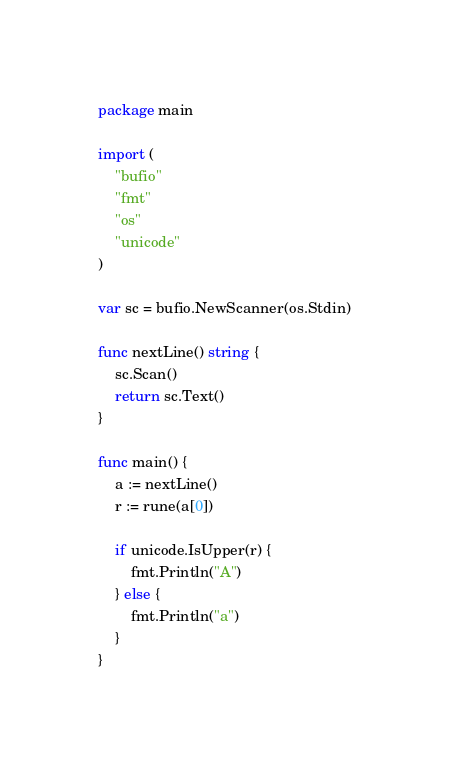<code> <loc_0><loc_0><loc_500><loc_500><_Go_>package main

import (
	"bufio"
	"fmt"
	"os"
	"unicode"
)

var sc = bufio.NewScanner(os.Stdin)

func nextLine() string {
	sc.Scan()
	return sc.Text()
}

func main() {
	a := nextLine()
	r := rune(a[0])

	if unicode.IsUpper(r) {
		fmt.Println("A")
	} else {
		fmt.Println("a")
	}
}
</code> 